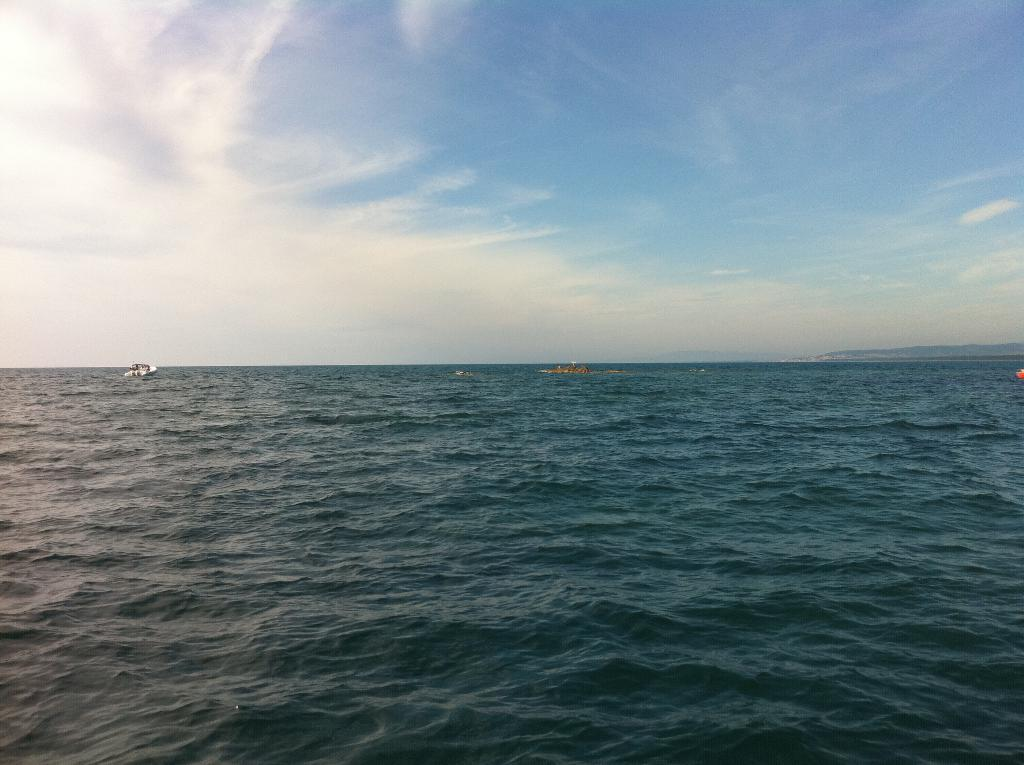What type of vehicles are in the image? There are boats in the image. Where are the boats located? The boats are on the water. What can be seen in the background of the image? There is sky visible in the background of the image. What type of paper can be seen smashing the substance in the image? There is no paper or substance present in the image; it features boats on the water with sky in the background. 